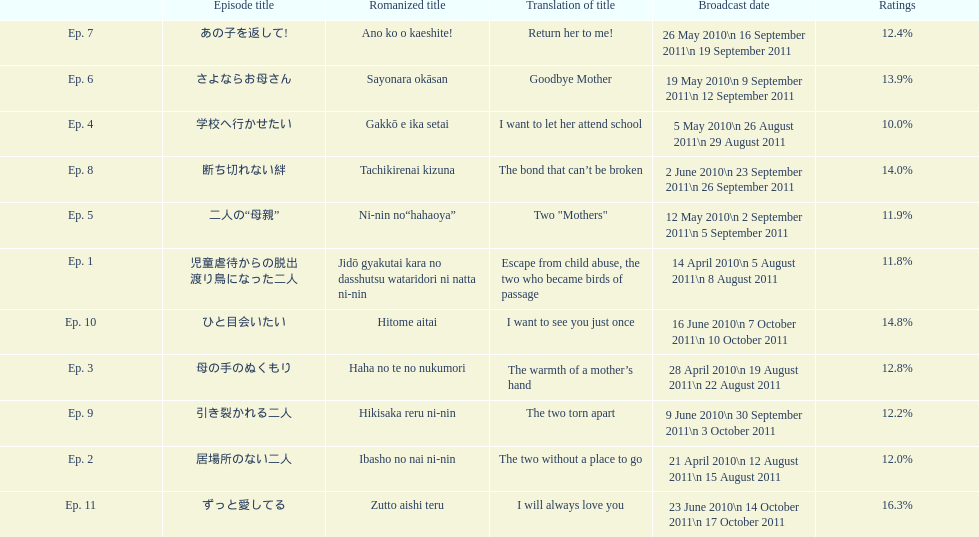Other than the 10th episode, which other episode has a 14% rating? Ep. 8. 